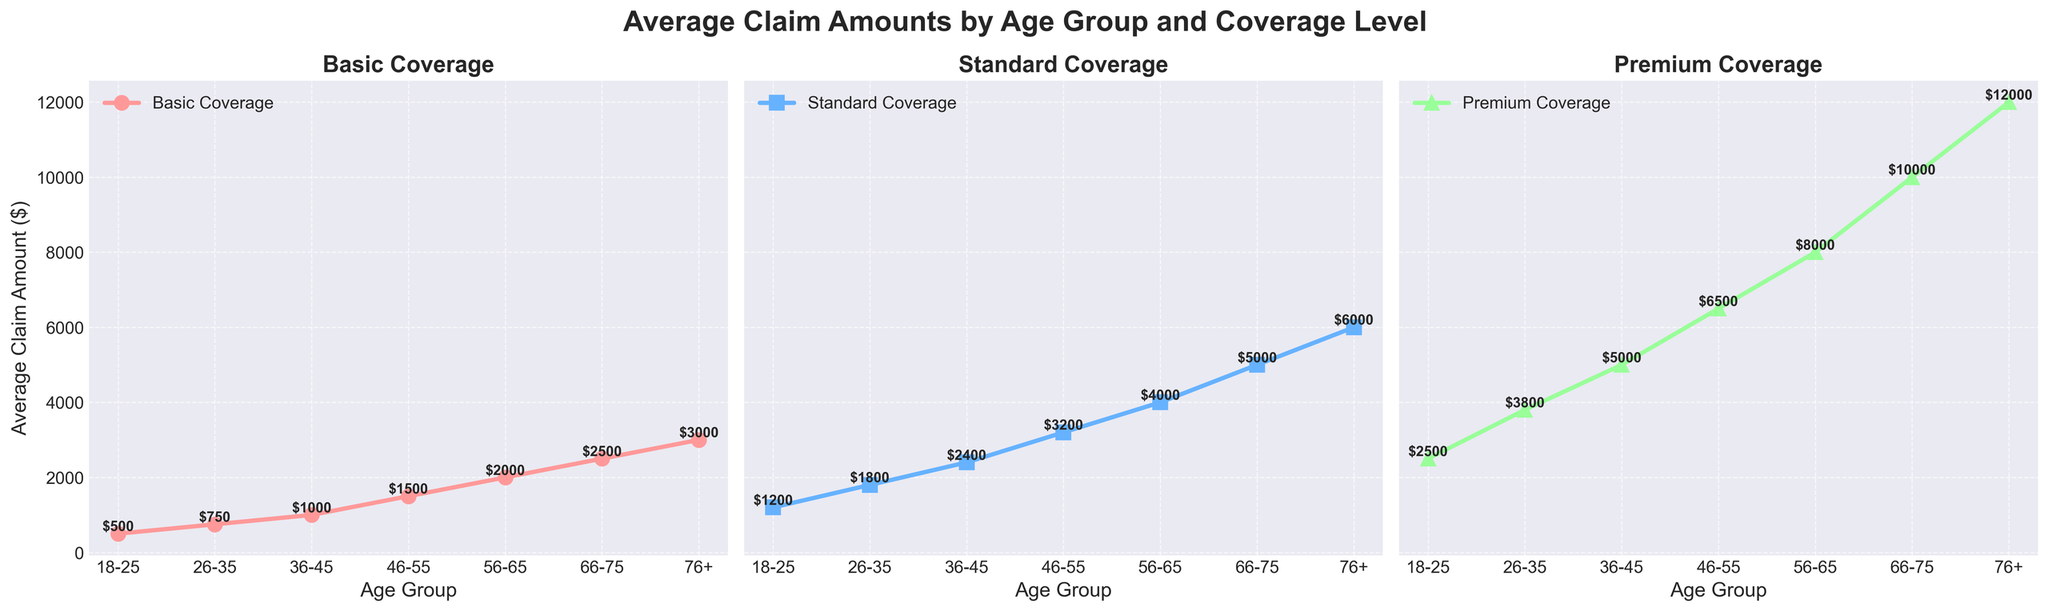Which age group has the highest average claim amount for Premium Coverage? The '76+' age group has the highest line in the Premium Coverage subplot. By reading the value at the end of the line, it is $12,000.
Answer: 76+ Compare the average claim amount for Standard Coverage between the age groups 36-45 and 46-55. Which age group has a higher amount? Looking at the Standard Coverage subplot, the point for the 46-55 age group is higher than the point for the 36-45 age group. The values are $3,200 for 46-55 and $2,400 for 36-45.
Answer: 46-55 What is the difference in average claim amounts between the youngest and oldest age groups for Basic Coverage? For the youngest age group (18-25) in Basic Coverage, the amount is $500. For the oldest age group (76+), it is $3,000. The difference is $3,000 - $500.
Answer: $2,500 Which age group has the least average claim amount in the Standard Coverage category? In the Standard Coverage subplot, the 18-25 age group has the lowest point. The value is $1,200.
Answer: 18-25 What is the sum of the average claim amounts for Basic Coverage and Premium Coverage for the 56-65 age group? For the 56-65 age group, the Basic Coverage claim amount is $2,000 and the Premium Coverage claim amount is $8,000. The sum is $2,000 + $8,000.
Answer: $10,000 How does the average claim amount for 66-75 year-olds in Basic Coverage compare to Standard Coverage? In the Basic Coverage subplot, the 66-75 age group has a claim amount of $2,500. In the Standard Coverage subplot, it is $5,000. The value for Standard Coverage is higher.
Answer: Standard Coverage is higher Identify the age group with the maximum difference in average claim amounts between Basic and Premium Coverage. What is this difference? For each age group, calculate the difference between Premium and Basic Coverage. The maximum difference is for age group 76+ with Premium Coverage at $12,000 and Basic Coverage at $3,000, resulting in a difference of $12,000 - $3,000.
Answer: 76+, $9,000 Compare the slope of the line segments in the Standard Coverage plot for the age groups 18-25 to 26-35 and 26-35 to 36-45. Which has a steeper increase? The increase from 18-25 ($1,200) to 26-35 ($1,800) is $600. The increase from 26-35 ($1,800) to 36-45 ($2,400) is also $600. Both segments have the same increase.
Answer: Both have the same increase What is the average claim amount for the age group 46-55 across all three coverage levels? Add the amounts from each subplot for the 46-55 age group: Basic Coverage ($1,500), Standard Coverage ($3,200), and Premium Coverage ($6,500). Sum is $1,500 + $3,200 + $6,500 = $11,200. Average is $11,200 / 3.
Answer: $3,733.33 What trend do you observe in average claim amounts across age groups for all coverage types? For all subplots, there is an increasing trend in average claim amounts as age groups progress from younger to older. As age increases, the claim amounts for all coverage levels also increase.
Answer: Increasing trend 